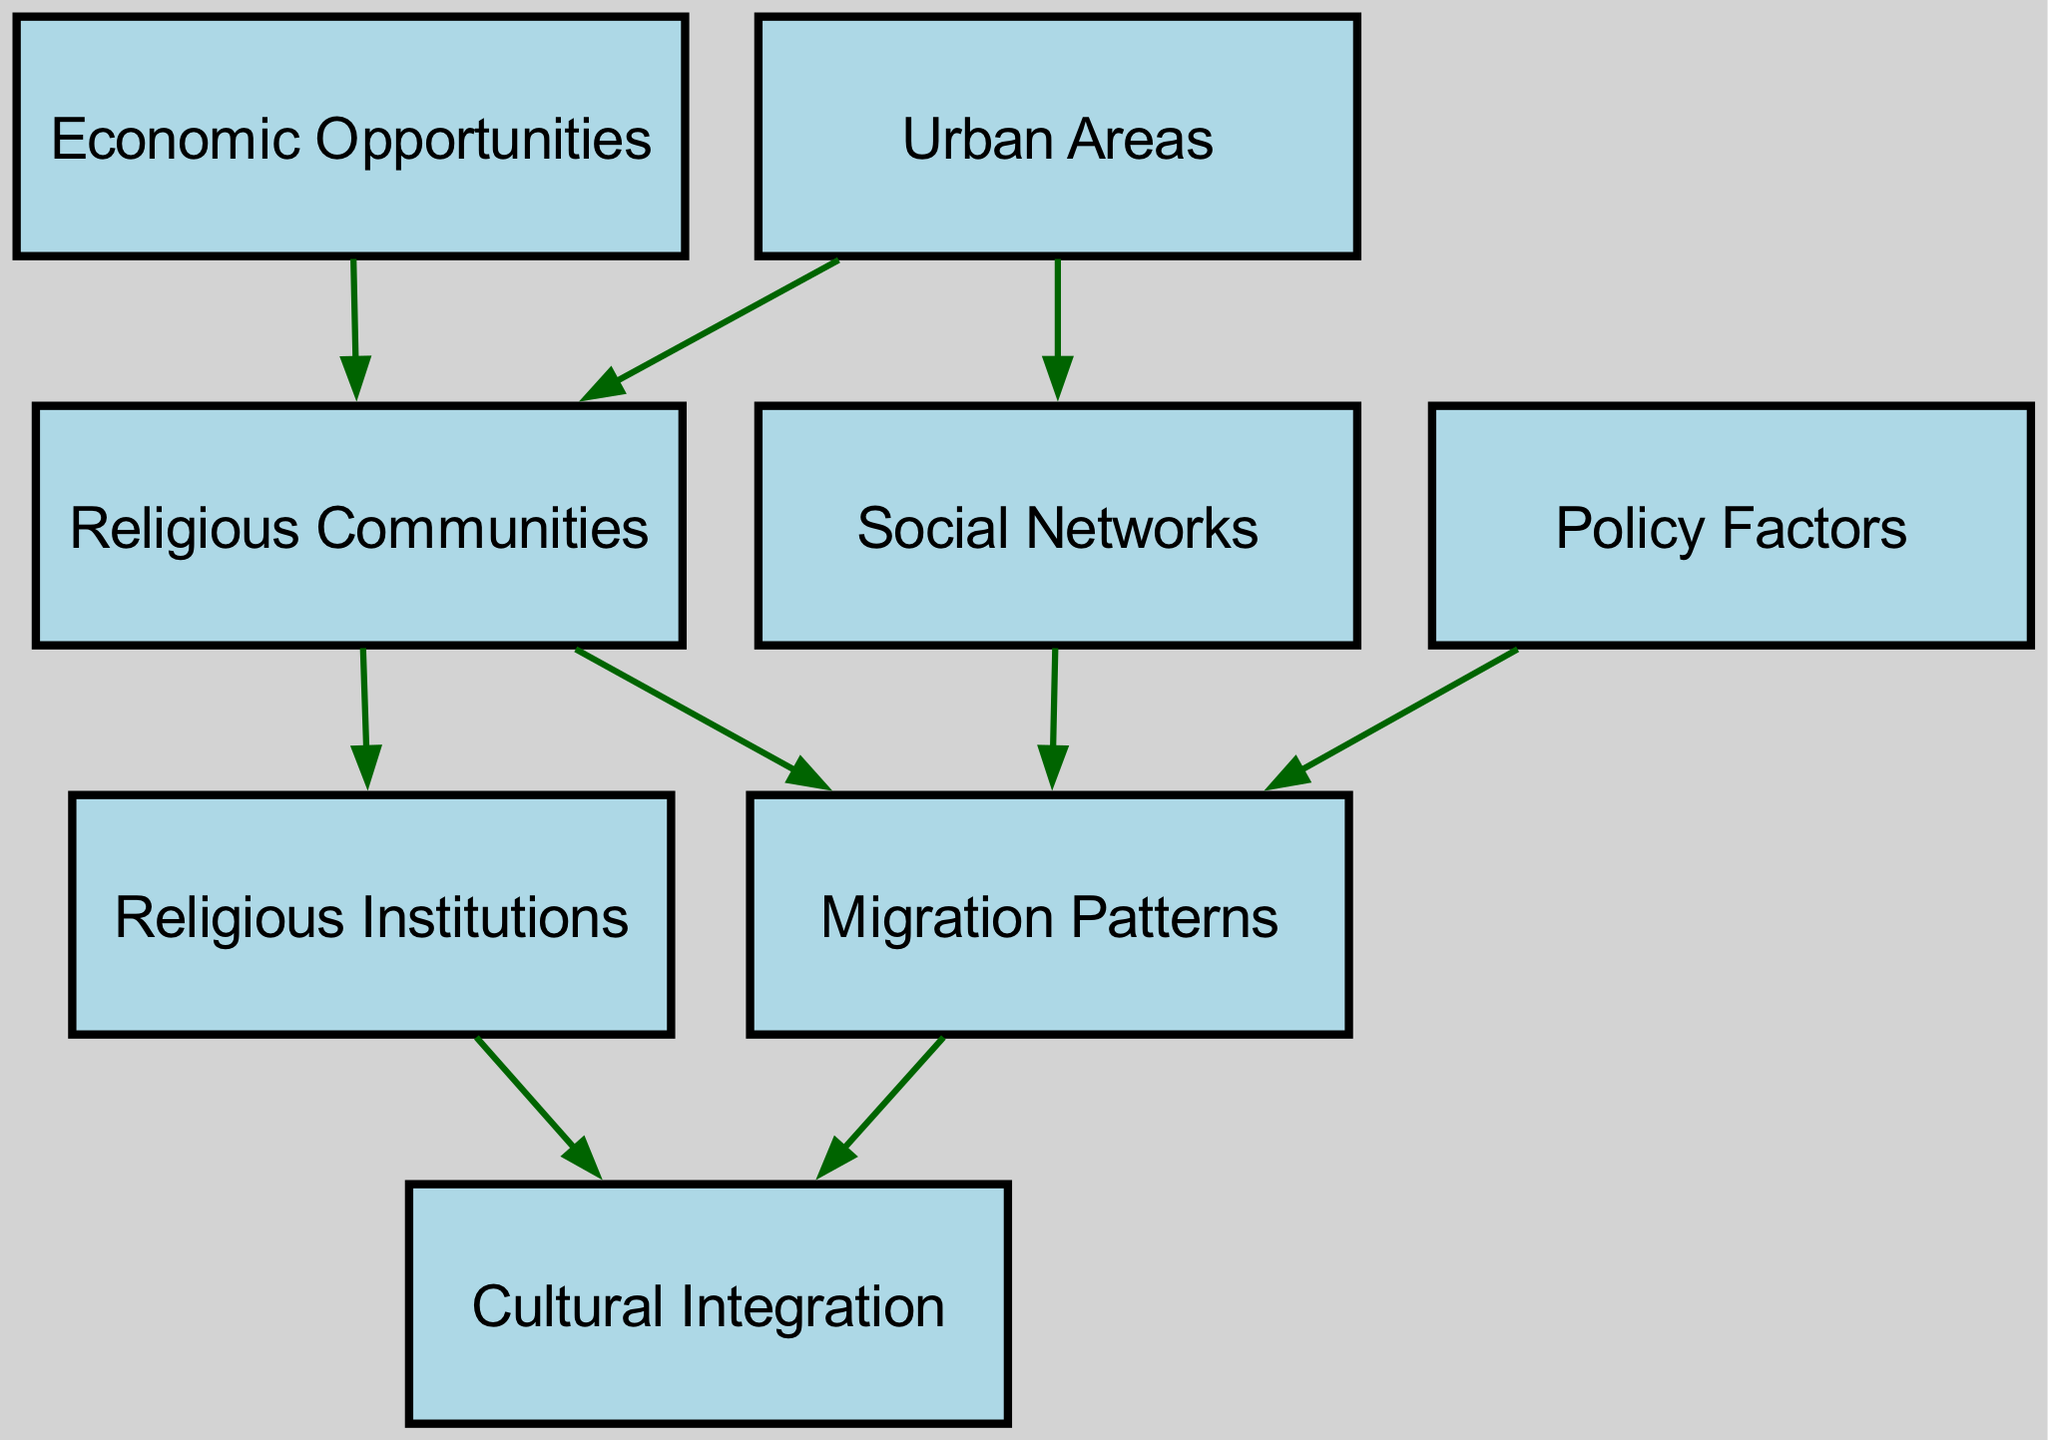What nodes are present in the diagram? The diagram contains eight nodes: Urban Areas, Religious Communities, Migration Patterns, Cultural Integration, Religious Institutions, Social Networks, Policy Factors, and Economic Opportunities.
Answer: Urban Areas, Religious Communities, Migration Patterns, Cultural Integration, Religious Institutions, Social Networks, Policy Factors, Economic Opportunities How many edges are there in total? By counting the connections between the nodes, there are a total of nine edges present in the diagram.
Answer: 9 What is the relationship between Urban Areas and Religious Communities? The edge connecting Urban Areas to Religious Communities indicates that urban areas influence the presence of religious communities.
Answer: Urban Areas influence Religious Communities What leads to Cultural Integration? Cultural Integration is influenced by two nodes: Migration Patterns and Religious Institutions, as both have direct edges leading to it.
Answer: Migration Patterns, Religious Institutions Which nodes are directly linked to Migration Patterns? The Migration Patterns node has direct connections to the nodes for Religious Communities, Cultural Integration, Social Networks, and Policy Factors.
Answer: Religious Communities, Cultural Integration, Social Networks, Policy Factors How do Economic Opportunities affect Religious Communities? The diagram shows that Economic Opportunities have a direct edge leading to Religious Communities, indicating that these opportunities play a role in their migration patterns.
Answer: Economic Opportunities influence Religious Communities What role do Social Networks play in Migration Patterns? Social Networks directly connect to Migration Patterns in the diagram, suggesting they facilitate or influence how migration occurs among religious communities.
Answer: Social Networks facilitate Migration Patterns What influences Migration Patterns the most? The diagram indicates that several factors, including Policy Factors and Social Networks, influence Migration Patterns. However, a clear leading factor cannot be concluded without specific weights or context.
Answer: Policy Factors, Social Networks (multiple influences) Is there a direct connection between Religious Communities and Cultural Integration? Yes, Religious Institutions connect to Cultural Integration, showing that these institutions play a role in the cultural blending within communities.
Answer: Yes, through Religious Institutions 